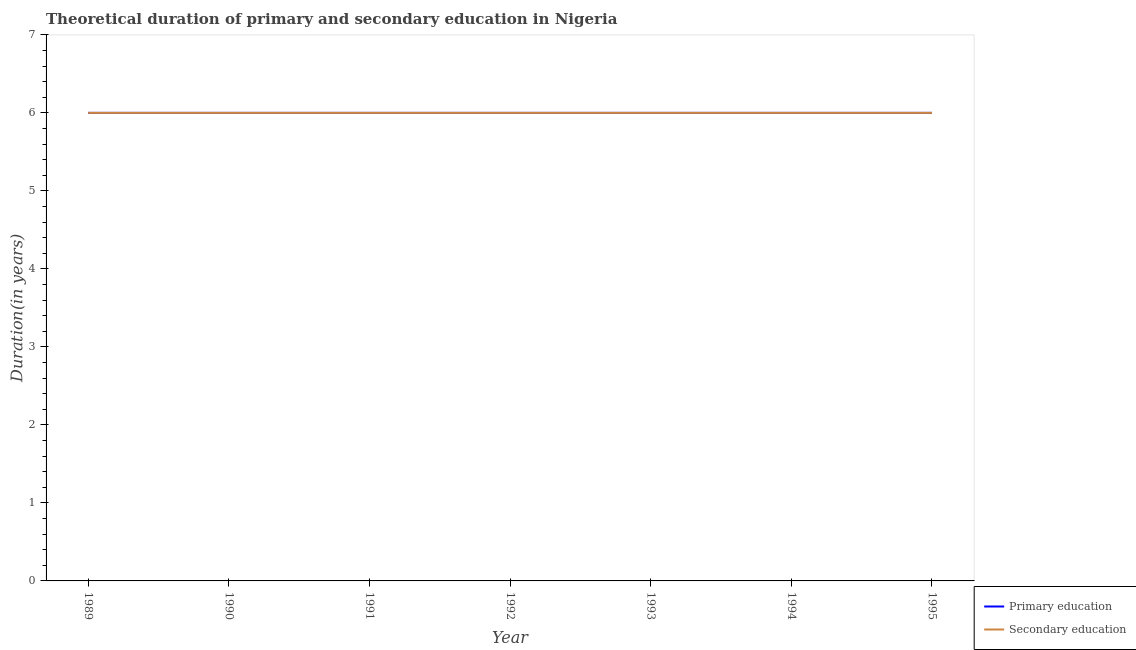Across all years, what is the maximum duration of secondary education?
Your answer should be very brief. 6. In which year was the duration of secondary education maximum?
Provide a succinct answer. 1989. What is the total duration of primary education in the graph?
Make the answer very short. 42. What is the difference between the duration of secondary education in 1994 and the duration of primary education in 1993?
Offer a terse response. 0. Is the difference between the duration of secondary education in 1993 and 1995 greater than the difference between the duration of primary education in 1993 and 1995?
Offer a very short reply. No. What is the difference between the highest and the second highest duration of secondary education?
Give a very brief answer. 0. What is the difference between the highest and the lowest duration of primary education?
Ensure brevity in your answer.  0. Is the sum of the duration of secondary education in 1990 and 1995 greater than the maximum duration of primary education across all years?
Give a very brief answer. Yes. Does the duration of secondary education monotonically increase over the years?
Offer a very short reply. No. Is the duration of secondary education strictly greater than the duration of primary education over the years?
Give a very brief answer. No. How many years are there in the graph?
Offer a terse response. 7. What is the difference between two consecutive major ticks on the Y-axis?
Offer a very short reply. 1. Does the graph contain any zero values?
Your response must be concise. No. How many legend labels are there?
Provide a succinct answer. 2. How are the legend labels stacked?
Offer a terse response. Vertical. What is the title of the graph?
Your answer should be compact. Theoretical duration of primary and secondary education in Nigeria. Does "Central government" appear as one of the legend labels in the graph?
Make the answer very short. No. What is the label or title of the Y-axis?
Offer a very short reply. Duration(in years). What is the Duration(in years) of Primary education in 1990?
Ensure brevity in your answer.  6. What is the Duration(in years) in Secondary education in 1990?
Ensure brevity in your answer.  6. What is the Duration(in years) of Primary education in 1991?
Provide a succinct answer. 6. What is the Duration(in years) in Secondary education in 1993?
Make the answer very short. 6. What is the Duration(in years) in Primary education in 1994?
Your answer should be very brief. 6. What is the Duration(in years) in Primary education in 1995?
Provide a short and direct response. 6. What is the Duration(in years) in Secondary education in 1995?
Provide a short and direct response. 6. Across all years, what is the maximum Duration(in years) in Primary education?
Offer a very short reply. 6. Across all years, what is the maximum Duration(in years) of Secondary education?
Ensure brevity in your answer.  6. Across all years, what is the minimum Duration(in years) in Primary education?
Keep it short and to the point. 6. What is the total Duration(in years) of Primary education in the graph?
Provide a succinct answer. 42. What is the difference between the Duration(in years) in Primary education in 1989 and that in 1990?
Keep it short and to the point. 0. What is the difference between the Duration(in years) in Secondary education in 1989 and that in 1990?
Offer a very short reply. 0. What is the difference between the Duration(in years) of Primary education in 1989 and that in 1991?
Your answer should be compact. 0. What is the difference between the Duration(in years) of Primary education in 1989 and that in 1993?
Offer a very short reply. 0. What is the difference between the Duration(in years) of Secondary education in 1989 and that in 1994?
Offer a very short reply. 0. What is the difference between the Duration(in years) in Primary education in 1989 and that in 1995?
Ensure brevity in your answer.  0. What is the difference between the Duration(in years) in Secondary education in 1990 and that in 1991?
Offer a terse response. 0. What is the difference between the Duration(in years) of Primary education in 1990 and that in 1993?
Make the answer very short. 0. What is the difference between the Duration(in years) in Secondary education in 1990 and that in 1994?
Provide a short and direct response. 0. What is the difference between the Duration(in years) of Primary education in 1990 and that in 1995?
Ensure brevity in your answer.  0. What is the difference between the Duration(in years) in Secondary education in 1990 and that in 1995?
Provide a succinct answer. 0. What is the difference between the Duration(in years) in Secondary education in 1991 and that in 1993?
Offer a very short reply. 0. What is the difference between the Duration(in years) of Primary education in 1991 and that in 1994?
Make the answer very short. 0. What is the difference between the Duration(in years) in Secondary education in 1991 and that in 1994?
Your answer should be compact. 0. What is the difference between the Duration(in years) in Primary education in 1991 and that in 1995?
Offer a terse response. 0. What is the difference between the Duration(in years) of Primary education in 1992 and that in 1993?
Offer a terse response. 0. What is the difference between the Duration(in years) in Secondary education in 1992 and that in 1994?
Make the answer very short. 0. What is the difference between the Duration(in years) of Primary education in 1992 and that in 1995?
Keep it short and to the point. 0. What is the difference between the Duration(in years) of Secondary education in 1992 and that in 1995?
Give a very brief answer. 0. What is the difference between the Duration(in years) in Secondary education in 1993 and that in 1994?
Ensure brevity in your answer.  0. What is the difference between the Duration(in years) in Primary education in 1993 and that in 1995?
Your answer should be very brief. 0. What is the difference between the Duration(in years) of Primary education in 1994 and that in 1995?
Your response must be concise. 0. What is the difference between the Duration(in years) of Primary education in 1989 and the Duration(in years) of Secondary education in 1992?
Give a very brief answer. 0. What is the difference between the Duration(in years) in Primary education in 1989 and the Duration(in years) in Secondary education in 1993?
Give a very brief answer. 0. What is the difference between the Duration(in years) of Primary education in 1989 and the Duration(in years) of Secondary education in 1994?
Your answer should be very brief. 0. What is the difference between the Duration(in years) in Primary education in 1990 and the Duration(in years) in Secondary education in 1991?
Provide a short and direct response. 0. What is the difference between the Duration(in years) in Primary education in 1990 and the Duration(in years) in Secondary education in 1992?
Provide a succinct answer. 0. What is the difference between the Duration(in years) in Primary education in 1990 and the Duration(in years) in Secondary education in 1993?
Give a very brief answer. 0. What is the difference between the Duration(in years) in Primary education in 1991 and the Duration(in years) in Secondary education in 1992?
Offer a terse response. 0. What is the difference between the Duration(in years) in Primary education in 1991 and the Duration(in years) in Secondary education in 1993?
Your response must be concise. 0. What is the difference between the Duration(in years) of Primary education in 1991 and the Duration(in years) of Secondary education in 1995?
Offer a terse response. 0. What is the difference between the Duration(in years) in Primary education in 1992 and the Duration(in years) in Secondary education in 1993?
Provide a short and direct response. 0. What is the difference between the Duration(in years) in Primary education in 1994 and the Duration(in years) in Secondary education in 1995?
Provide a succinct answer. 0. In the year 1990, what is the difference between the Duration(in years) in Primary education and Duration(in years) in Secondary education?
Your answer should be compact. 0. In the year 1991, what is the difference between the Duration(in years) of Primary education and Duration(in years) of Secondary education?
Keep it short and to the point. 0. In the year 1992, what is the difference between the Duration(in years) of Primary education and Duration(in years) of Secondary education?
Offer a very short reply. 0. In the year 1993, what is the difference between the Duration(in years) in Primary education and Duration(in years) in Secondary education?
Provide a short and direct response. 0. In the year 1995, what is the difference between the Duration(in years) of Primary education and Duration(in years) of Secondary education?
Make the answer very short. 0. What is the ratio of the Duration(in years) in Secondary education in 1989 to that in 1991?
Ensure brevity in your answer.  1. What is the ratio of the Duration(in years) of Primary education in 1989 to that in 1992?
Offer a terse response. 1. What is the ratio of the Duration(in years) of Secondary education in 1989 to that in 1992?
Your answer should be compact. 1. What is the ratio of the Duration(in years) of Primary education in 1989 to that in 1993?
Ensure brevity in your answer.  1. What is the ratio of the Duration(in years) of Secondary education in 1989 to that in 1993?
Offer a very short reply. 1. What is the ratio of the Duration(in years) in Primary education in 1989 to that in 1994?
Offer a very short reply. 1. What is the ratio of the Duration(in years) of Primary education in 1989 to that in 1995?
Offer a very short reply. 1. What is the ratio of the Duration(in years) in Primary education in 1990 to that in 1991?
Your response must be concise. 1. What is the ratio of the Duration(in years) of Secondary education in 1990 to that in 1991?
Provide a short and direct response. 1. What is the ratio of the Duration(in years) in Secondary education in 1990 to that in 1992?
Your answer should be compact. 1. What is the ratio of the Duration(in years) in Primary education in 1990 to that in 1994?
Offer a terse response. 1. What is the ratio of the Duration(in years) in Primary education in 1990 to that in 1995?
Provide a succinct answer. 1. What is the ratio of the Duration(in years) in Secondary education in 1990 to that in 1995?
Provide a short and direct response. 1. What is the ratio of the Duration(in years) in Secondary education in 1991 to that in 1992?
Your answer should be compact. 1. What is the ratio of the Duration(in years) in Secondary education in 1991 to that in 1993?
Provide a short and direct response. 1. What is the ratio of the Duration(in years) of Secondary education in 1991 to that in 1994?
Give a very brief answer. 1. What is the ratio of the Duration(in years) of Secondary education in 1992 to that in 1993?
Offer a very short reply. 1. What is the ratio of the Duration(in years) in Primary education in 1992 to that in 1994?
Offer a very short reply. 1. What is the ratio of the Duration(in years) of Secondary education in 1992 to that in 1994?
Your answer should be very brief. 1. What is the ratio of the Duration(in years) of Primary education in 1992 to that in 1995?
Your answer should be compact. 1. What is the ratio of the Duration(in years) of Secondary education in 1992 to that in 1995?
Offer a terse response. 1. What is the ratio of the Duration(in years) of Primary education in 1993 to that in 1994?
Give a very brief answer. 1. What is the ratio of the Duration(in years) of Secondary education in 1993 to that in 1994?
Offer a terse response. 1. What is the ratio of the Duration(in years) in Secondary education in 1993 to that in 1995?
Your answer should be very brief. 1. What is the ratio of the Duration(in years) in Primary education in 1994 to that in 1995?
Offer a terse response. 1. What is the ratio of the Duration(in years) in Secondary education in 1994 to that in 1995?
Your answer should be very brief. 1. What is the difference between the highest and the second highest Duration(in years) of Primary education?
Your response must be concise. 0. What is the difference between the highest and the second highest Duration(in years) in Secondary education?
Offer a very short reply. 0. What is the difference between the highest and the lowest Duration(in years) in Primary education?
Provide a short and direct response. 0. 